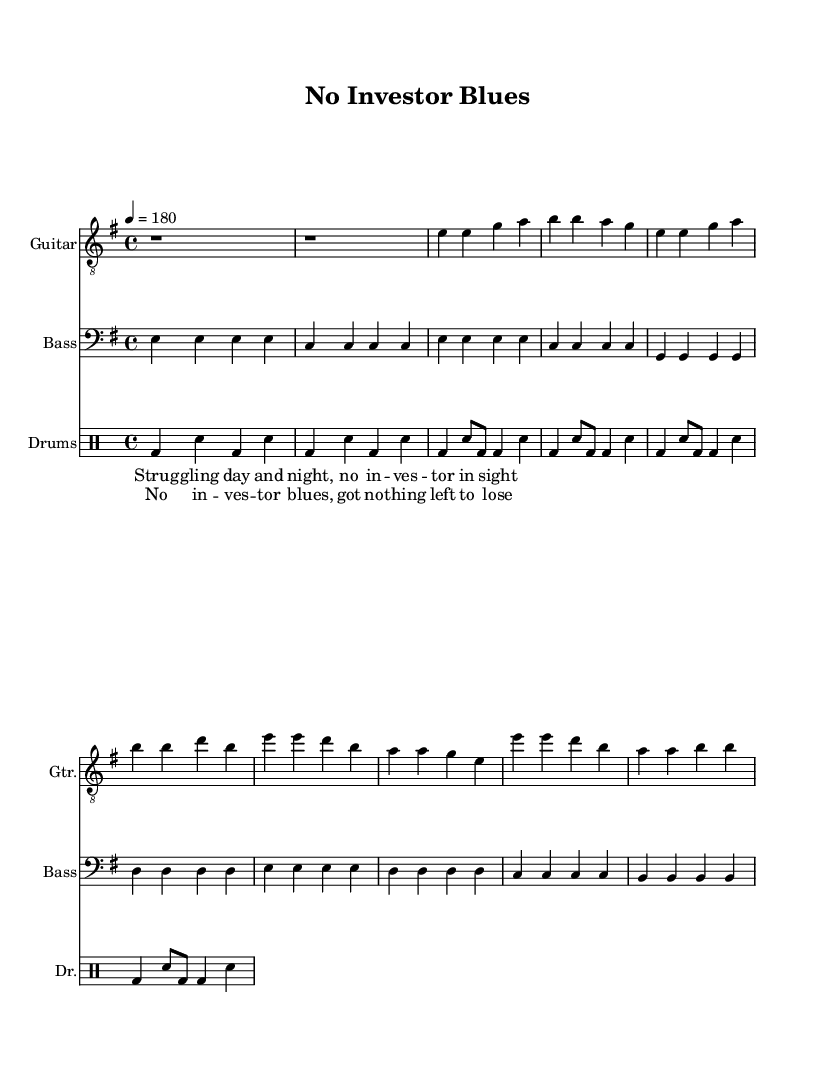What is the key signature of this music? The key signature is E minor, which includes one sharp (F#). This can be identified at the beginning of the staff where the sharps are indicated.
Answer: E minor What is the time signature of this music? The time signature is 4/4, which means there are four beats in each measure and the quarter note gets one beat. This can be seen at the beginning of the sheet music where the time is indicated.
Answer: 4/4 What is the tempo marking for this piece? The tempo marking is 180 beats per minute, which is specified in the global section of the code. It suggests a fast-paced performance typical for punk music.
Answer: 180 How many measures are in the verse section? The verse section consists of four measures, which can be counted by analyzing the rhythmic notation and identifying the measures marked by the bar lines.
Answer: Four What type of lyrics are used in this song? The lyrics reflect frustration, encapsulating the struggles of small business owners through a punk lens. They are straightforward and confrontational, typical of the punk genre.
Answer: Frustration What characterizes the rhythm pattern for the drums in the chorus? The rhythm pattern for the drums in the chorus features a consistent kick-snare-kick-snare pattern across the measures, creating a driving force that complements the energetic feel of punk music.
Answer: Driving pattern What is the general theme of the song based on the lyrics? The general theme revolves around the struggles of finding investment and the resulting frustration, which is a critical point of focus for small business owners as expressed in the lyrics.
Answer: Struggles of investment 